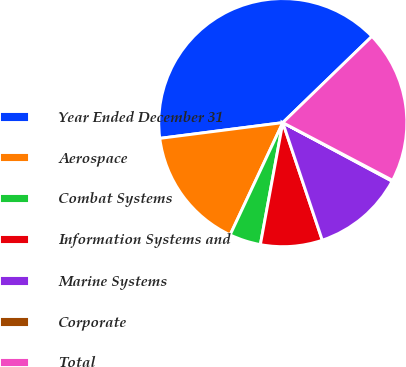<chart> <loc_0><loc_0><loc_500><loc_500><pie_chart><fcel>Year Ended December 31<fcel>Aerospace<fcel>Combat Systems<fcel>Information Systems and<fcel>Marine Systems<fcel>Corporate<fcel>Total<nl><fcel>39.79%<fcel>15.99%<fcel>4.09%<fcel>8.05%<fcel>12.02%<fcel>0.12%<fcel>19.95%<nl></chart> 